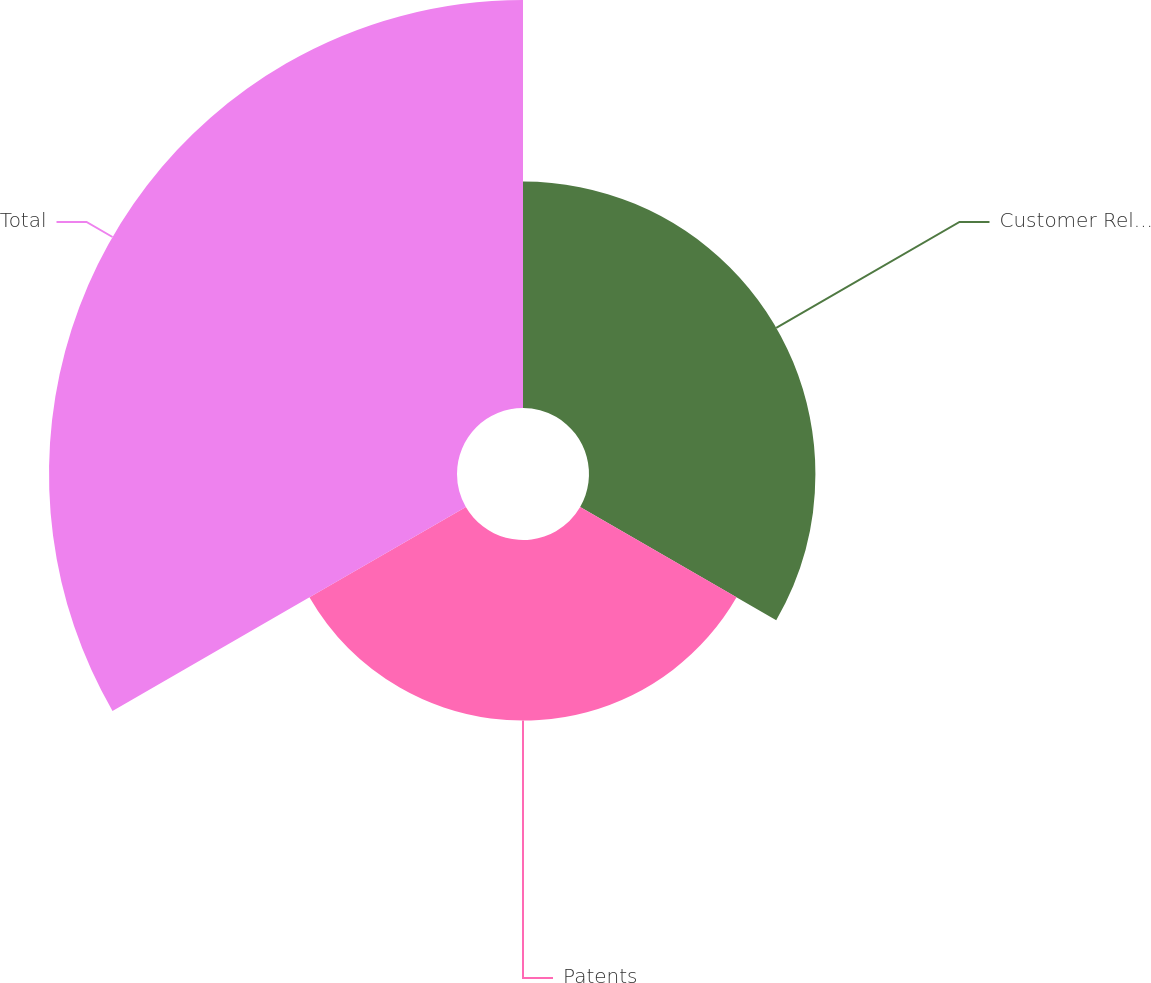<chart> <loc_0><loc_0><loc_500><loc_500><pie_chart><fcel>Customer Relationships<fcel>Patents<fcel>Total<nl><fcel>27.78%<fcel>22.16%<fcel>50.06%<nl></chart> 